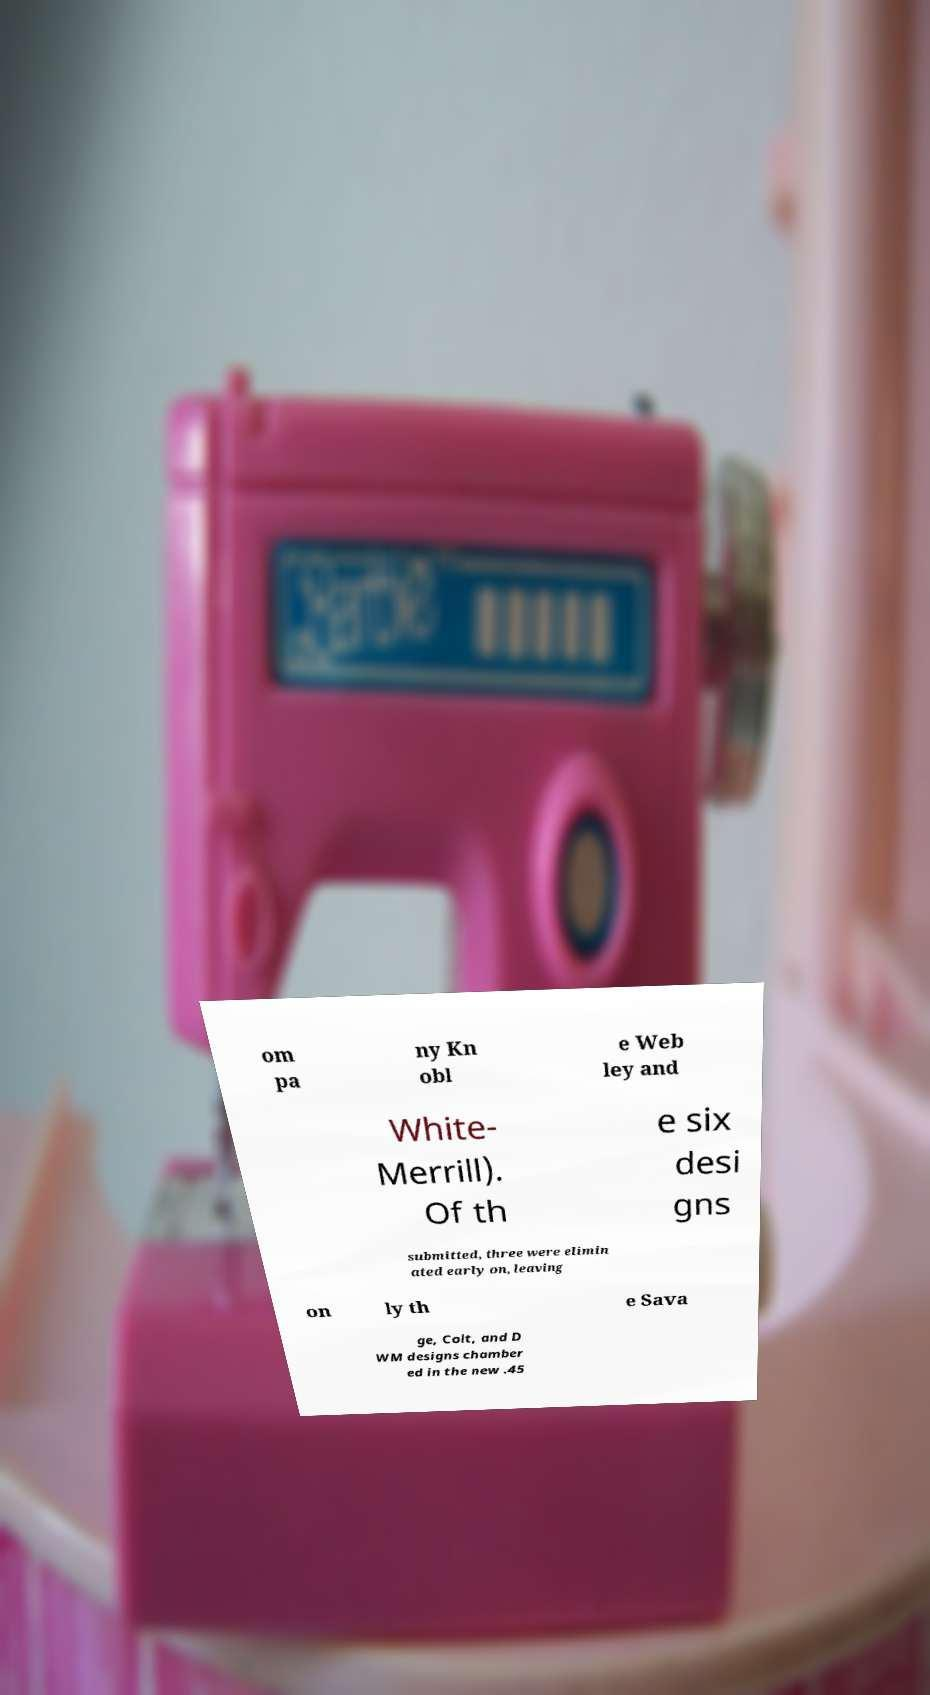Please read and relay the text visible in this image. What does it say? om pa ny Kn obl e Web ley and White- Merrill). Of th e six desi gns submitted, three were elimin ated early on, leaving on ly th e Sava ge, Colt, and D WM designs chamber ed in the new .45 